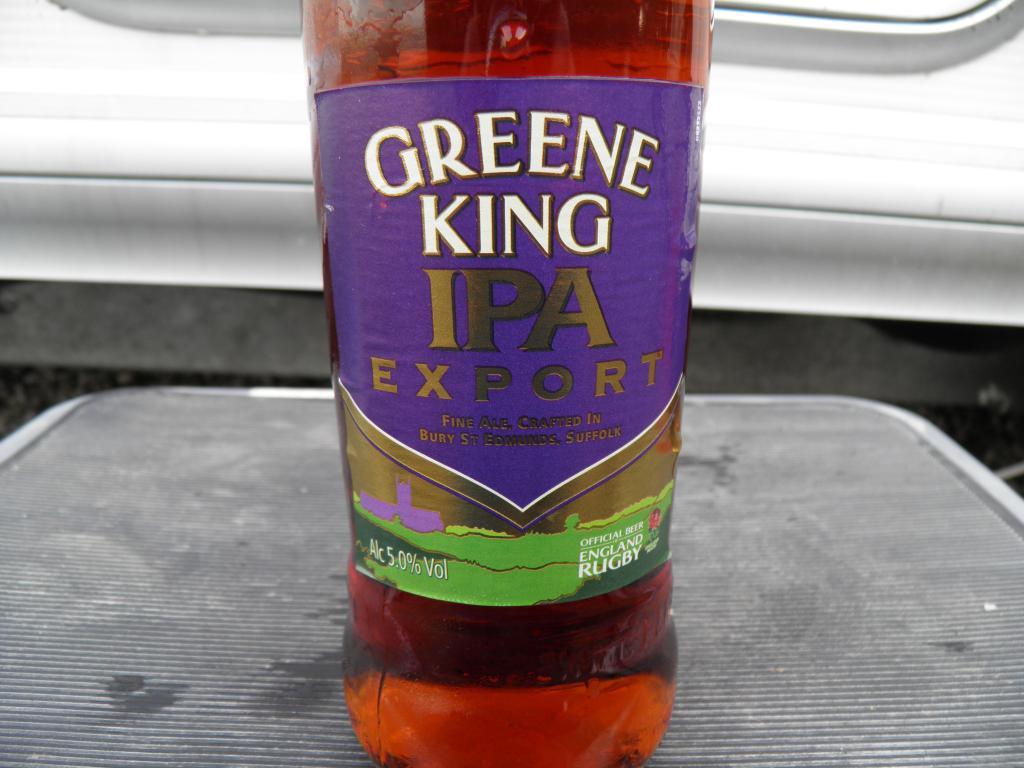What variety of beer is this?
Offer a terse response. Ipa. 